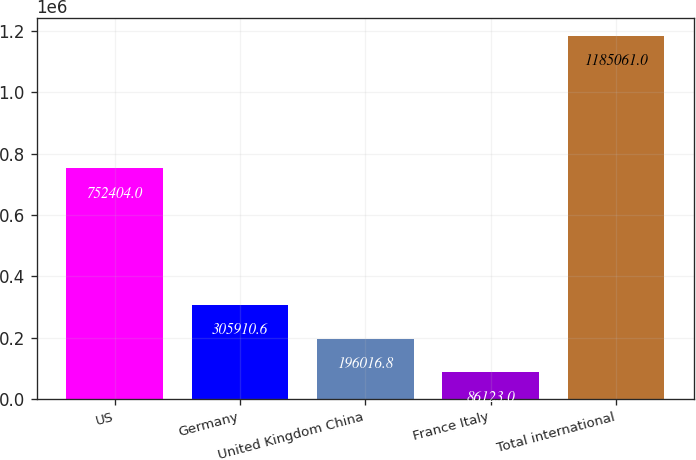<chart> <loc_0><loc_0><loc_500><loc_500><bar_chart><fcel>US<fcel>Germany<fcel>United Kingdom China<fcel>France Italy<fcel>Total international<nl><fcel>752404<fcel>305911<fcel>196017<fcel>86123<fcel>1.18506e+06<nl></chart> 